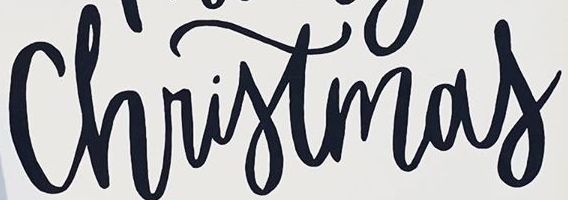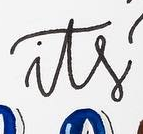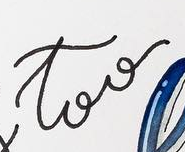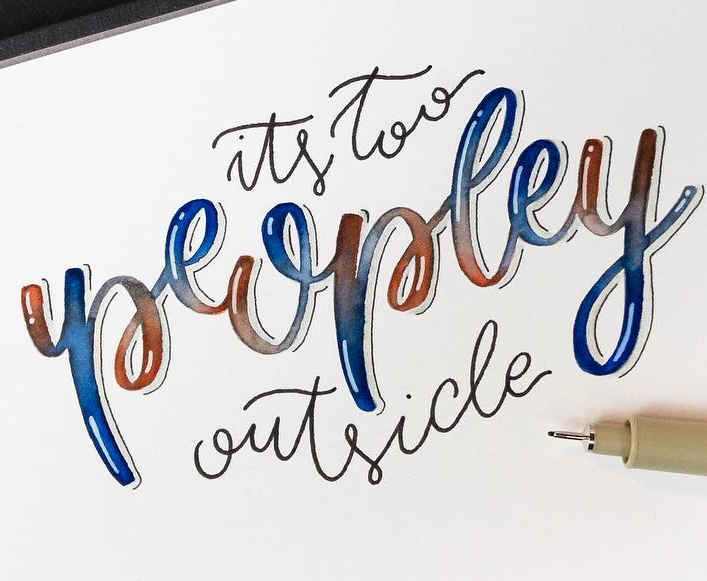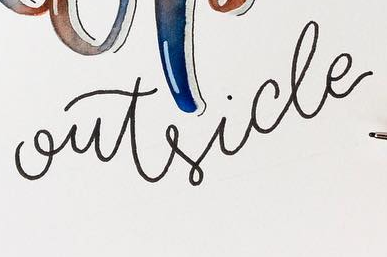What words are shown in these images in order, separated by a semicolon? Christmas; its; too; peopley; outside 